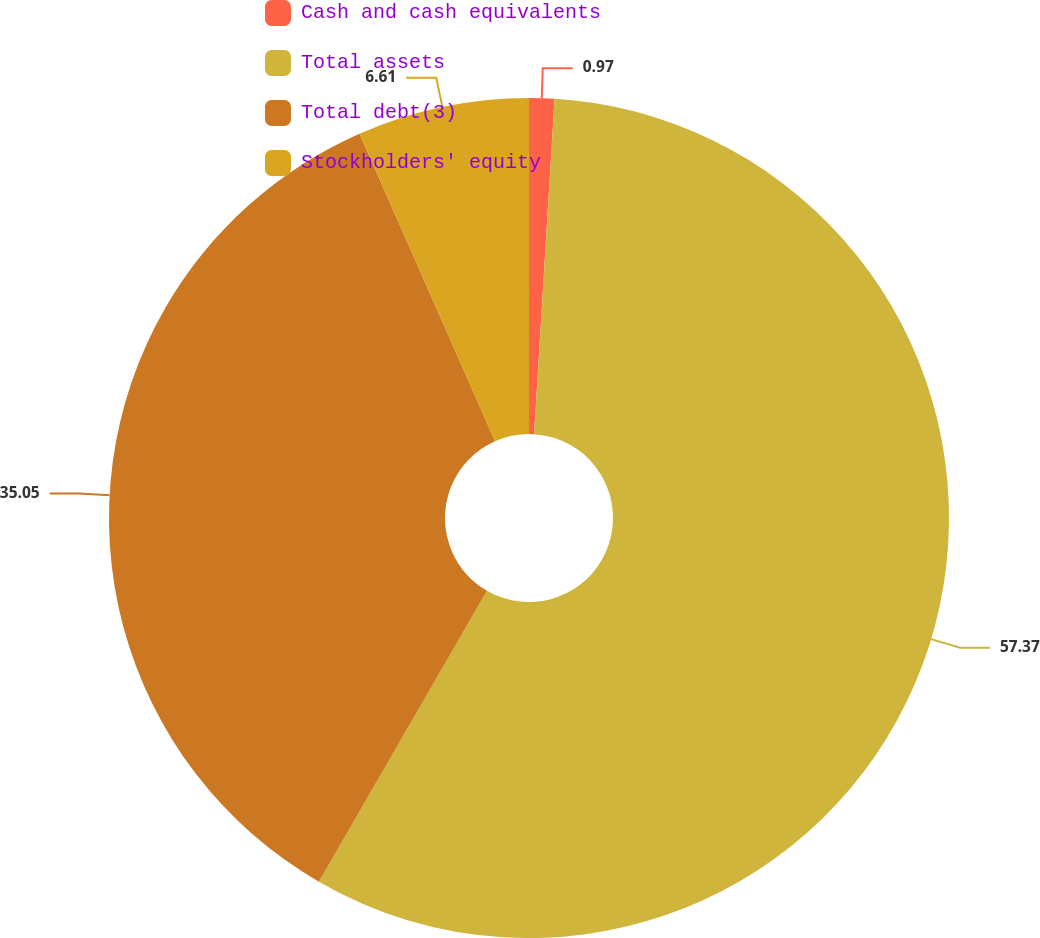Convert chart to OTSL. <chart><loc_0><loc_0><loc_500><loc_500><pie_chart><fcel>Cash and cash equivalents<fcel>Total assets<fcel>Total debt(3)<fcel>Stockholders' equity<nl><fcel>0.97%<fcel>57.37%<fcel>35.05%<fcel>6.61%<nl></chart> 